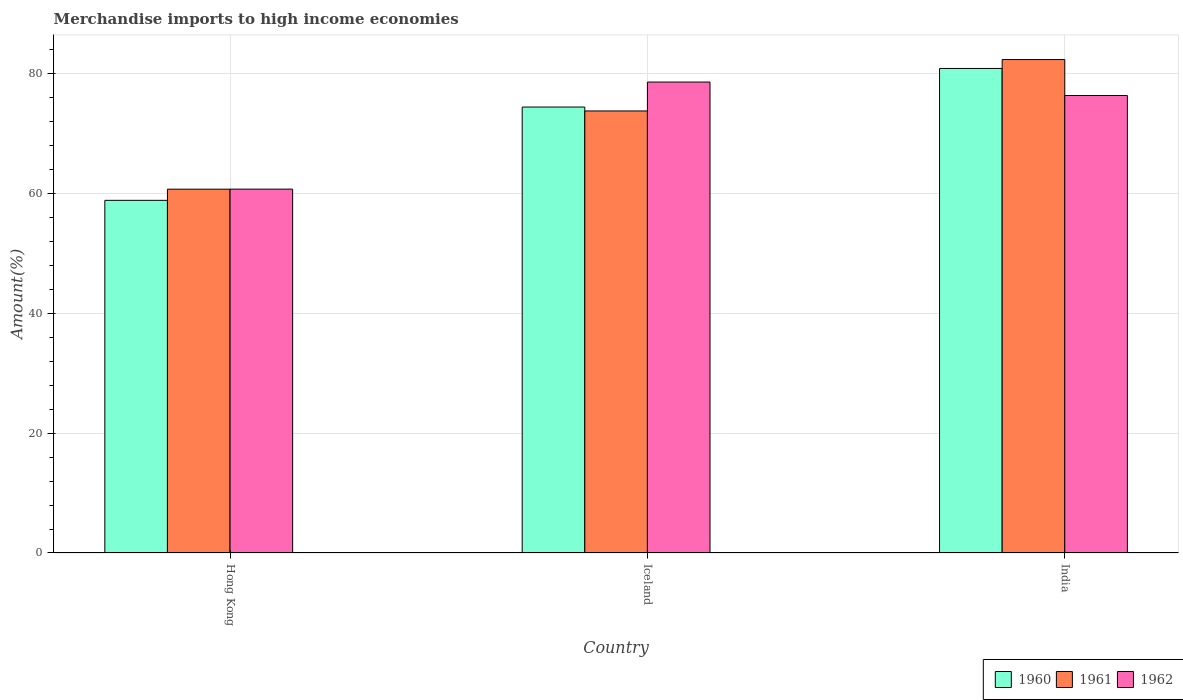How many different coloured bars are there?
Provide a short and direct response. 3. Are the number of bars per tick equal to the number of legend labels?
Give a very brief answer. Yes. How many bars are there on the 1st tick from the right?
Keep it short and to the point. 3. What is the label of the 1st group of bars from the left?
Your response must be concise. Hong Kong. In how many cases, is the number of bars for a given country not equal to the number of legend labels?
Offer a terse response. 0. What is the percentage of amount earned from merchandise imports in 1962 in India?
Make the answer very short. 76.29. Across all countries, what is the maximum percentage of amount earned from merchandise imports in 1960?
Your answer should be very brief. 80.81. Across all countries, what is the minimum percentage of amount earned from merchandise imports in 1962?
Your answer should be very brief. 60.68. In which country was the percentage of amount earned from merchandise imports in 1962 maximum?
Make the answer very short. Iceland. In which country was the percentage of amount earned from merchandise imports in 1960 minimum?
Keep it short and to the point. Hong Kong. What is the total percentage of amount earned from merchandise imports in 1962 in the graph?
Keep it short and to the point. 215.52. What is the difference between the percentage of amount earned from merchandise imports in 1962 in Iceland and that in India?
Provide a short and direct response. 2.25. What is the difference between the percentage of amount earned from merchandise imports in 1961 in Iceland and the percentage of amount earned from merchandise imports in 1960 in Hong Kong?
Make the answer very short. 14.91. What is the average percentage of amount earned from merchandise imports in 1961 per country?
Give a very brief answer. 72.23. What is the difference between the percentage of amount earned from merchandise imports of/in 1962 and percentage of amount earned from merchandise imports of/in 1961 in Iceland?
Your answer should be very brief. 4.82. What is the ratio of the percentage of amount earned from merchandise imports in 1961 in Hong Kong to that in Iceland?
Keep it short and to the point. 0.82. What is the difference between the highest and the second highest percentage of amount earned from merchandise imports in 1962?
Your response must be concise. -2.25. What is the difference between the highest and the lowest percentage of amount earned from merchandise imports in 1960?
Your response must be concise. 22. Is the sum of the percentage of amount earned from merchandise imports in 1962 in Hong Kong and Iceland greater than the maximum percentage of amount earned from merchandise imports in 1960 across all countries?
Ensure brevity in your answer.  Yes. What does the 2nd bar from the left in Iceland represents?
Offer a terse response. 1961. Is it the case that in every country, the sum of the percentage of amount earned from merchandise imports in 1961 and percentage of amount earned from merchandise imports in 1962 is greater than the percentage of amount earned from merchandise imports in 1960?
Keep it short and to the point. Yes. How many bars are there?
Offer a terse response. 9. What is the difference between two consecutive major ticks on the Y-axis?
Offer a very short reply. 20. Does the graph contain any zero values?
Your answer should be compact. No. Where does the legend appear in the graph?
Give a very brief answer. Bottom right. How many legend labels are there?
Your response must be concise. 3. How are the legend labels stacked?
Give a very brief answer. Horizontal. What is the title of the graph?
Offer a terse response. Merchandise imports to high income economies. What is the label or title of the X-axis?
Your answer should be very brief. Country. What is the label or title of the Y-axis?
Keep it short and to the point. Amount(%). What is the Amount(%) of 1960 in Hong Kong?
Ensure brevity in your answer.  58.81. What is the Amount(%) of 1961 in Hong Kong?
Make the answer very short. 60.67. What is the Amount(%) in 1962 in Hong Kong?
Your response must be concise. 60.68. What is the Amount(%) of 1960 in Iceland?
Ensure brevity in your answer.  74.37. What is the Amount(%) in 1961 in Iceland?
Ensure brevity in your answer.  73.72. What is the Amount(%) in 1962 in Iceland?
Make the answer very short. 78.54. What is the Amount(%) in 1960 in India?
Offer a very short reply. 80.81. What is the Amount(%) of 1961 in India?
Offer a very short reply. 82.29. What is the Amount(%) in 1962 in India?
Your response must be concise. 76.29. Across all countries, what is the maximum Amount(%) of 1960?
Offer a terse response. 80.81. Across all countries, what is the maximum Amount(%) of 1961?
Your answer should be compact. 82.29. Across all countries, what is the maximum Amount(%) in 1962?
Make the answer very short. 78.54. Across all countries, what is the minimum Amount(%) in 1960?
Give a very brief answer. 58.81. Across all countries, what is the minimum Amount(%) of 1961?
Provide a short and direct response. 60.67. Across all countries, what is the minimum Amount(%) of 1962?
Ensure brevity in your answer.  60.68. What is the total Amount(%) in 1960 in the graph?
Your response must be concise. 213.99. What is the total Amount(%) of 1961 in the graph?
Give a very brief answer. 216.69. What is the total Amount(%) of 1962 in the graph?
Ensure brevity in your answer.  215.52. What is the difference between the Amount(%) of 1960 in Hong Kong and that in Iceland?
Provide a short and direct response. -15.56. What is the difference between the Amount(%) in 1961 in Hong Kong and that in Iceland?
Give a very brief answer. -13.05. What is the difference between the Amount(%) of 1962 in Hong Kong and that in Iceland?
Offer a terse response. -17.86. What is the difference between the Amount(%) of 1960 in Hong Kong and that in India?
Offer a very short reply. -22. What is the difference between the Amount(%) of 1961 in Hong Kong and that in India?
Keep it short and to the point. -21.62. What is the difference between the Amount(%) in 1962 in Hong Kong and that in India?
Your answer should be very brief. -15.61. What is the difference between the Amount(%) of 1960 in Iceland and that in India?
Your answer should be very brief. -6.43. What is the difference between the Amount(%) in 1961 in Iceland and that in India?
Ensure brevity in your answer.  -8.57. What is the difference between the Amount(%) in 1962 in Iceland and that in India?
Make the answer very short. 2.25. What is the difference between the Amount(%) of 1960 in Hong Kong and the Amount(%) of 1961 in Iceland?
Offer a terse response. -14.91. What is the difference between the Amount(%) of 1960 in Hong Kong and the Amount(%) of 1962 in Iceland?
Provide a succinct answer. -19.73. What is the difference between the Amount(%) in 1961 in Hong Kong and the Amount(%) in 1962 in Iceland?
Your response must be concise. -17.87. What is the difference between the Amount(%) of 1960 in Hong Kong and the Amount(%) of 1961 in India?
Make the answer very short. -23.48. What is the difference between the Amount(%) in 1960 in Hong Kong and the Amount(%) in 1962 in India?
Offer a terse response. -17.48. What is the difference between the Amount(%) of 1961 in Hong Kong and the Amount(%) of 1962 in India?
Give a very brief answer. -15.62. What is the difference between the Amount(%) of 1960 in Iceland and the Amount(%) of 1961 in India?
Provide a succinct answer. -7.92. What is the difference between the Amount(%) in 1960 in Iceland and the Amount(%) in 1962 in India?
Offer a terse response. -1.92. What is the difference between the Amount(%) of 1961 in Iceland and the Amount(%) of 1962 in India?
Provide a short and direct response. -2.57. What is the average Amount(%) in 1960 per country?
Offer a terse response. 71.33. What is the average Amount(%) in 1961 per country?
Offer a terse response. 72.23. What is the average Amount(%) in 1962 per country?
Keep it short and to the point. 71.84. What is the difference between the Amount(%) in 1960 and Amount(%) in 1961 in Hong Kong?
Provide a short and direct response. -1.86. What is the difference between the Amount(%) in 1960 and Amount(%) in 1962 in Hong Kong?
Your answer should be compact. -1.87. What is the difference between the Amount(%) in 1961 and Amount(%) in 1962 in Hong Kong?
Offer a terse response. -0.01. What is the difference between the Amount(%) of 1960 and Amount(%) of 1961 in Iceland?
Ensure brevity in your answer.  0.65. What is the difference between the Amount(%) in 1960 and Amount(%) in 1962 in Iceland?
Ensure brevity in your answer.  -4.17. What is the difference between the Amount(%) of 1961 and Amount(%) of 1962 in Iceland?
Your answer should be very brief. -4.82. What is the difference between the Amount(%) in 1960 and Amount(%) in 1961 in India?
Provide a short and direct response. -1.49. What is the difference between the Amount(%) of 1960 and Amount(%) of 1962 in India?
Your answer should be compact. 4.51. What is the difference between the Amount(%) in 1961 and Amount(%) in 1962 in India?
Offer a very short reply. 6. What is the ratio of the Amount(%) in 1960 in Hong Kong to that in Iceland?
Your answer should be compact. 0.79. What is the ratio of the Amount(%) in 1961 in Hong Kong to that in Iceland?
Keep it short and to the point. 0.82. What is the ratio of the Amount(%) of 1962 in Hong Kong to that in Iceland?
Your answer should be compact. 0.77. What is the ratio of the Amount(%) of 1960 in Hong Kong to that in India?
Make the answer very short. 0.73. What is the ratio of the Amount(%) in 1961 in Hong Kong to that in India?
Give a very brief answer. 0.74. What is the ratio of the Amount(%) in 1962 in Hong Kong to that in India?
Provide a succinct answer. 0.8. What is the ratio of the Amount(%) in 1960 in Iceland to that in India?
Give a very brief answer. 0.92. What is the ratio of the Amount(%) of 1961 in Iceland to that in India?
Your response must be concise. 0.9. What is the ratio of the Amount(%) in 1962 in Iceland to that in India?
Offer a very short reply. 1.03. What is the difference between the highest and the second highest Amount(%) in 1960?
Make the answer very short. 6.43. What is the difference between the highest and the second highest Amount(%) in 1961?
Offer a terse response. 8.57. What is the difference between the highest and the second highest Amount(%) of 1962?
Give a very brief answer. 2.25. What is the difference between the highest and the lowest Amount(%) in 1960?
Your answer should be very brief. 22. What is the difference between the highest and the lowest Amount(%) in 1961?
Offer a terse response. 21.62. What is the difference between the highest and the lowest Amount(%) in 1962?
Make the answer very short. 17.86. 